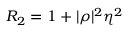<formula> <loc_0><loc_0><loc_500><loc_500>R _ { 2 } = 1 + | \rho | ^ { 2 } \eta ^ { 2 }</formula> 